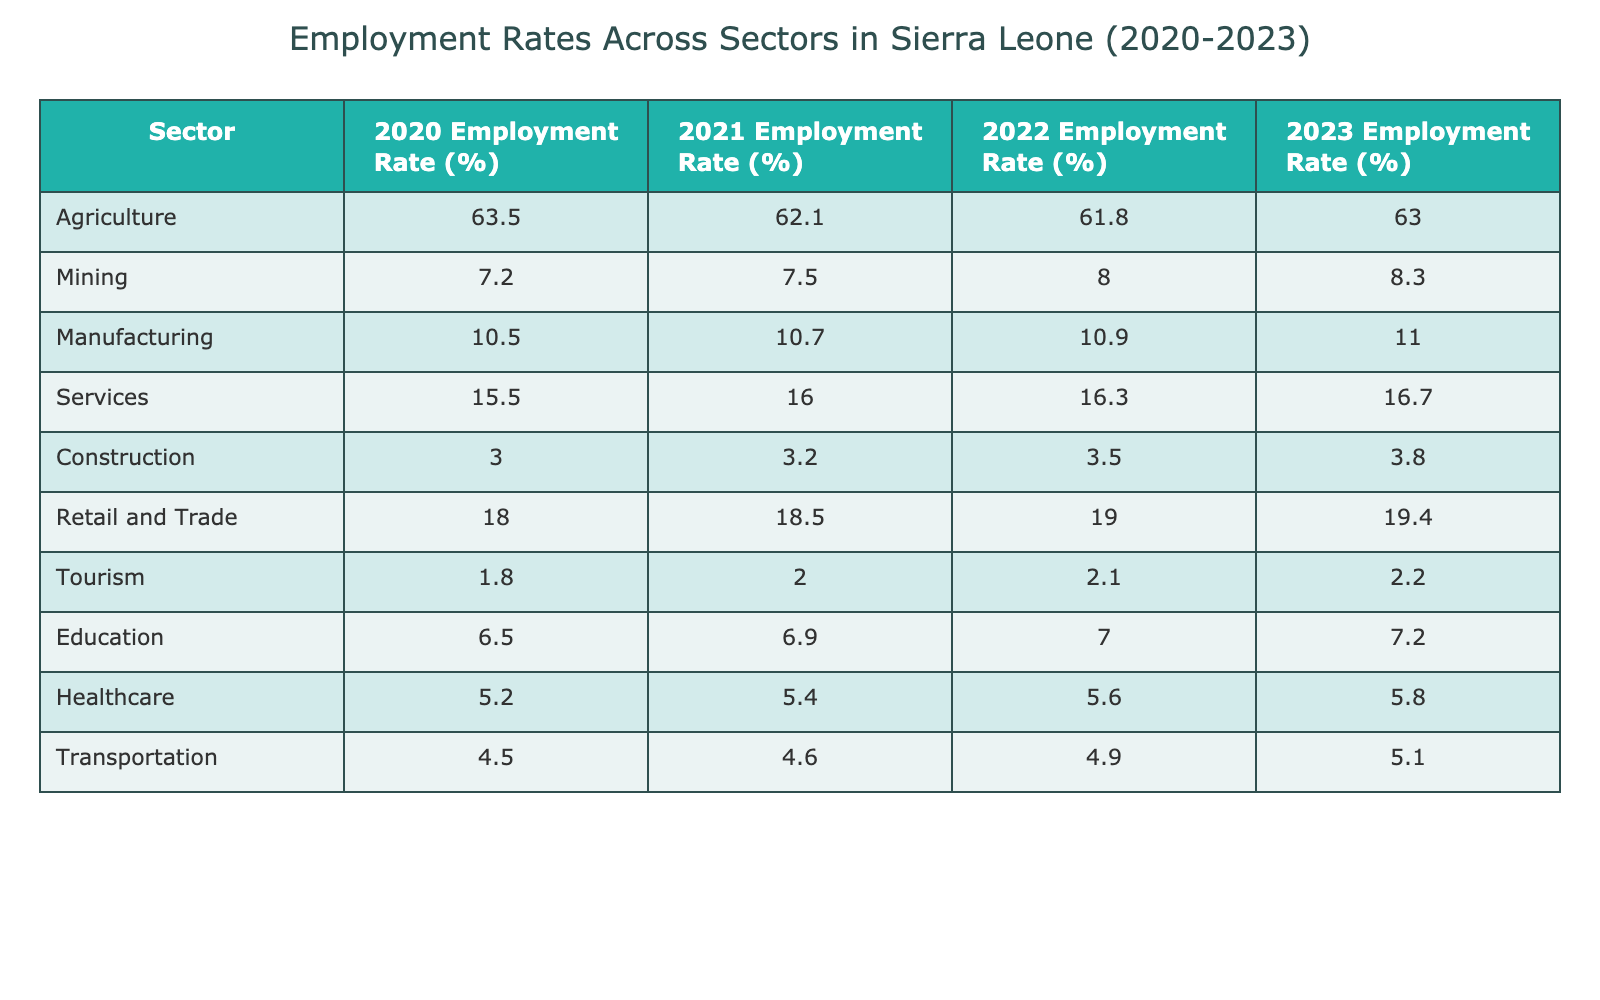What was the employment rate in the Agriculture sector in 2021? The table shows that the employment rate in the Agriculture sector for 2021 is 62.1%.
Answer: 62.1% Which sector had the highest employment rate in 2020? By examining the table, the Agriculture sector had the highest employment rate in 2020 at 63.5%.
Answer: Agriculture What is the difference in employment rate for the Mining sector between 2020 and 2023? The Mining sector employment rate in 2020 was 7.2%, and in 2023 it is 8.3%. The difference is 8.3% - 7.2% = 1.1%.
Answer: 1.1% Which sector had the lowest employment rate in 2022? The Tourism sector had the lowest employment rate in 2022, which was 2.1%.
Answer: Tourism What is the average employment rate for the Services sector from 2020 to 2023? The employment rates for the Services sector are 15.5%, 16.0%, 16.3%, and 16.7%. The sum is 15.5 + 16.0 + 16.3 + 16.7 = 64.5%. There are 4 years, so the average is 64.5% / 4 = 16.125%.
Answer: 16.125% In which year did the Retail and Trade sector see the highest increase in employment rate? The Retail and Trade sector increased from 18.0% in 2020 to 19.4% in 2023. The increases each year are: 0.5% (2021), 0.5% (2022), and 0.4% (2023). The highest increase was in 2021 and 2022, both at 0.5%.
Answer: 2021 and 2022 Is the trend for employment rates in the Construction sector increasing or decreasing from 2020 to 2023? The employment rates for the Construction sector are increasing: 3.0% in 2020, 3.2% in 2021, 3.5% in 2022, and 3.8% in 2023. Thus, the trend is increasing.
Answer: Increasing How does the employment rate for Healthcare in 2023 compare to that in Education in the same year? The table shows that the Healthcare sector had an employment rate of 5.8% and Education had 7.2% in 2023. So, Healthcare's rate is lower than Education's.
Answer: Lower Calculate the total employment rate for all sectors in 2022. The total employment for all sectors in 2022 is the sum of each sector’s employment rates: 61.8 + 8.0 + 10.9 + 16.3 + 3.5 + 19.0 + 2.1 + 7.0 + 5.6 + 4.9 = 139.1%.
Answer: 139.1% Did the Mining sector's employment rate exceed 8% in 2022? The Mining sector had an employment rate of 8.0% in 2022, which does not exceed 8%, so the answer is false.
Answer: No 